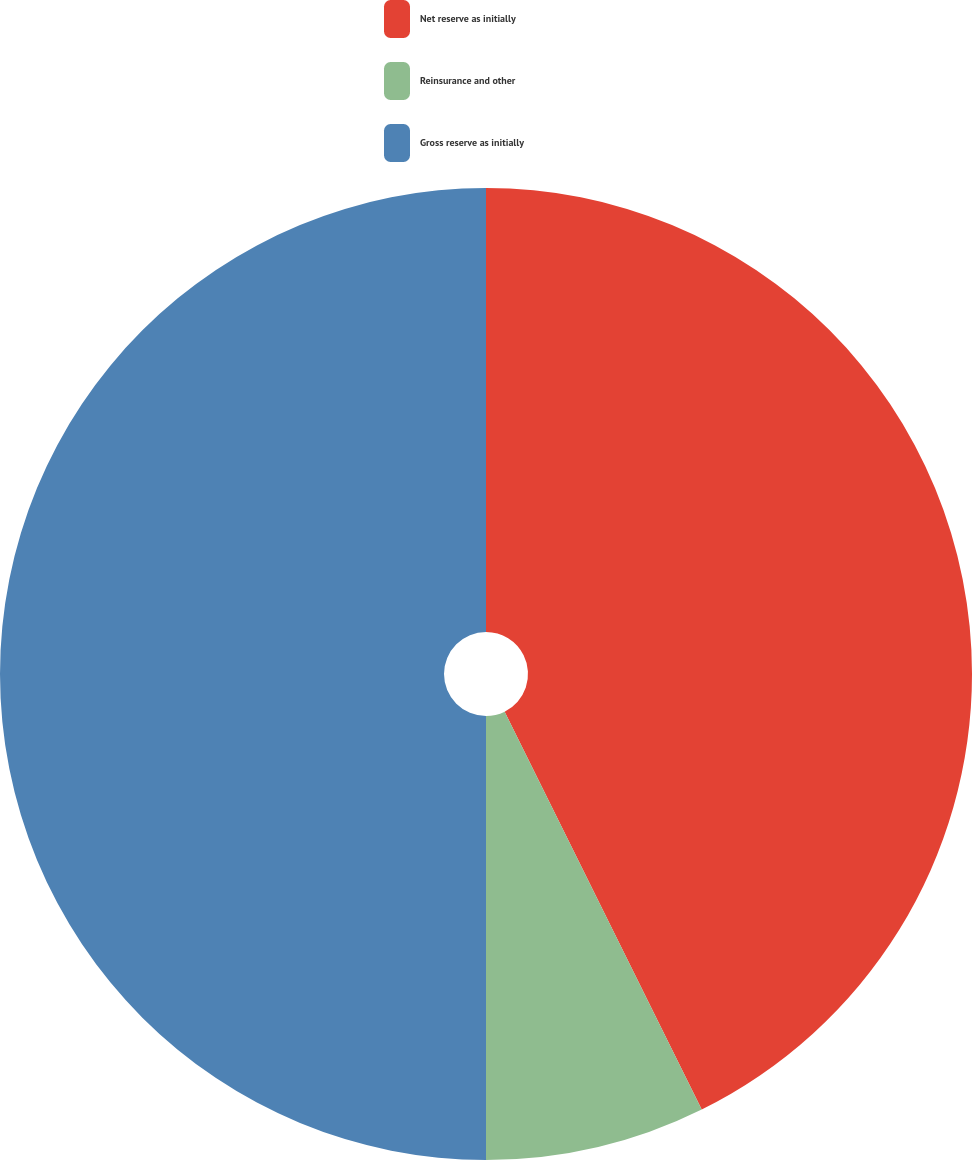<chart> <loc_0><loc_0><loc_500><loc_500><pie_chart><fcel>Net reserve as initially<fcel>Reinsurance and other<fcel>Gross reserve as initially<nl><fcel>42.68%<fcel>7.32%<fcel>50.0%<nl></chart> 